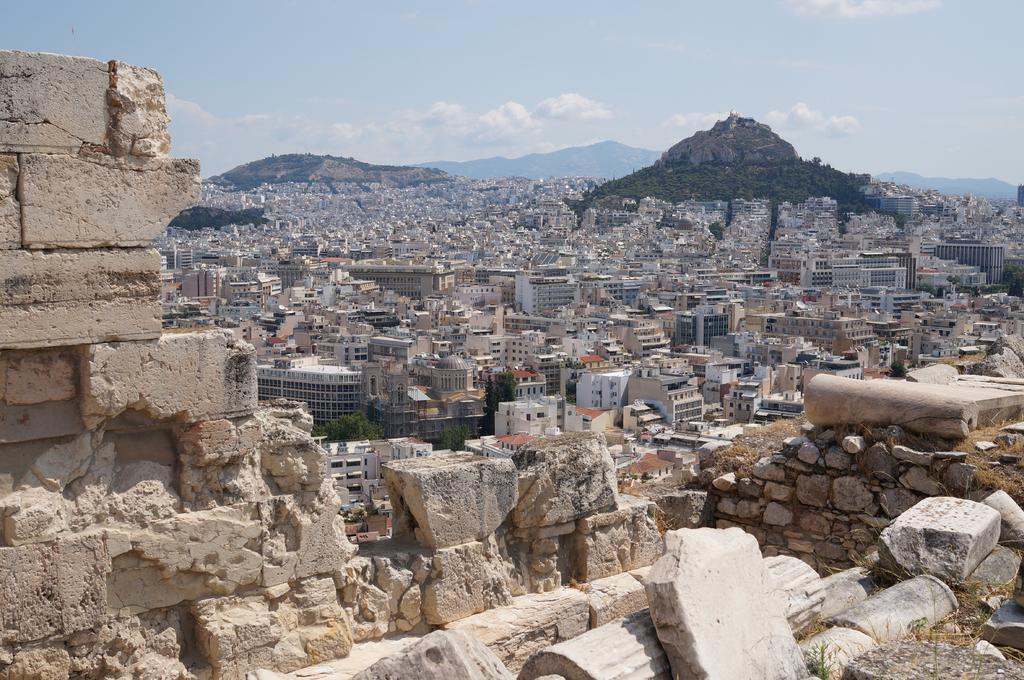What type of natural elements can be seen in the image? There are rocks and trees in the image. What type of man-made structures are present in the image? There are buildings in the image. What type of geographical feature can be seen in the image? There are hills in the image. What is visible in the background of the image? The sky is visible in the background of the image. What type of crime is being committed in the image? There is no crime being committed in the image; it features rocks, buildings, trees, hills, and the sky. What type of dish is being prepared on the plate in the image? There is no plate or cooking activity present in the image. 